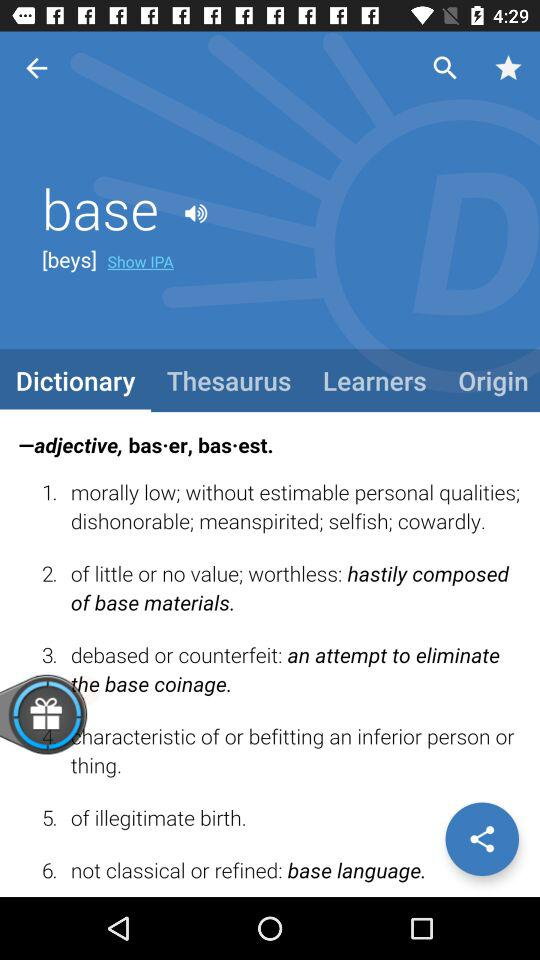Which tab am I on? You are on the tab "Dictionary". 